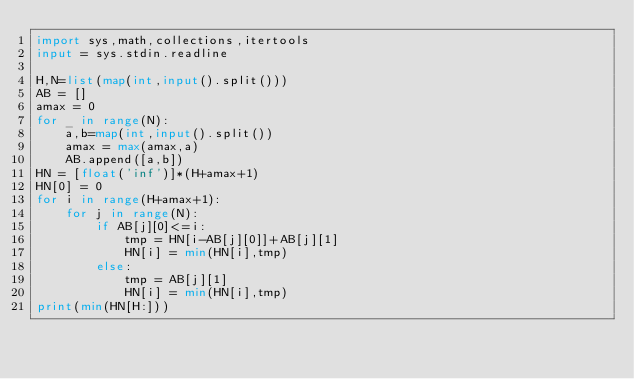Convert code to text. <code><loc_0><loc_0><loc_500><loc_500><_Python_>import sys,math,collections,itertools
input = sys.stdin.readline

H,N=list(map(int,input().split()))
AB = []
amax = 0
for _ in range(N):
    a,b=map(int,input().split())
    amax = max(amax,a)
    AB.append([a,b])
HN = [float('inf')]*(H+amax+1)
HN[0] = 0
for i in range(H+amax+1):
    for j in range(N):
        if AB[j][0]<=i:
            tmp = HN[i-AB[j][0]]+AB[j][1]
            HN[i] = min(HN[i],tmp)
        else:
            tmp = AB[j][1]
            HN[i] = min(HN[i],tmp)
print(min(HN[H:]))
</code> 